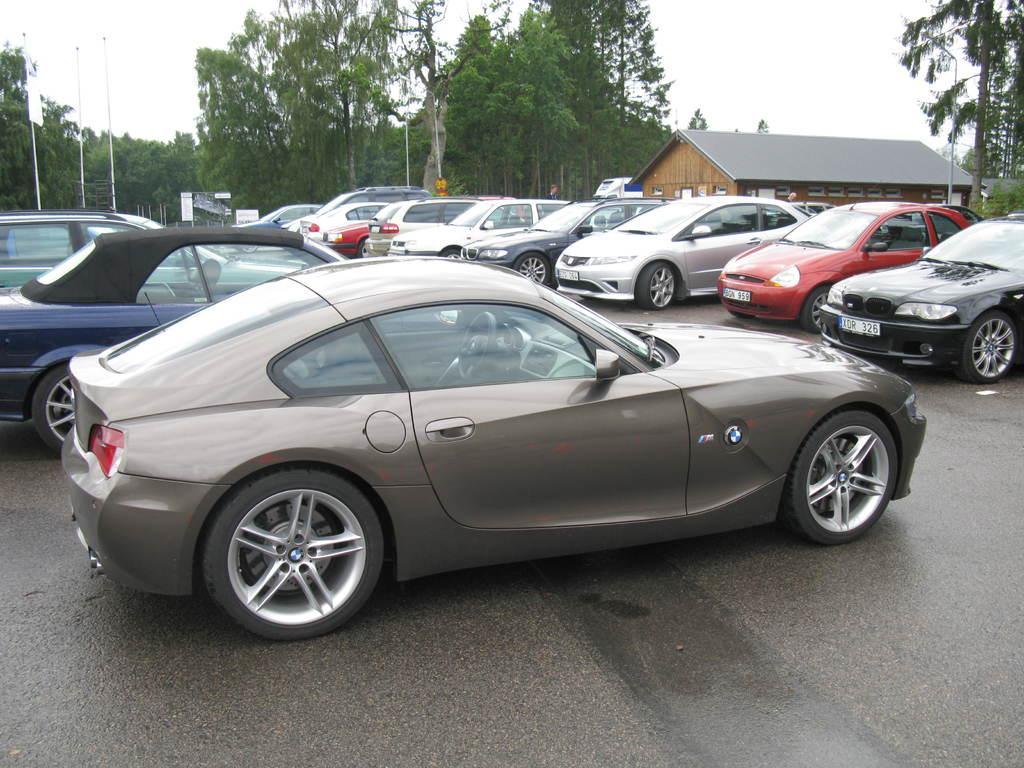Can you describe this image briefly? In this image we can see the vehicles parked on the road. We can also see a house, flag, poles, boards, trees and also the sky. 